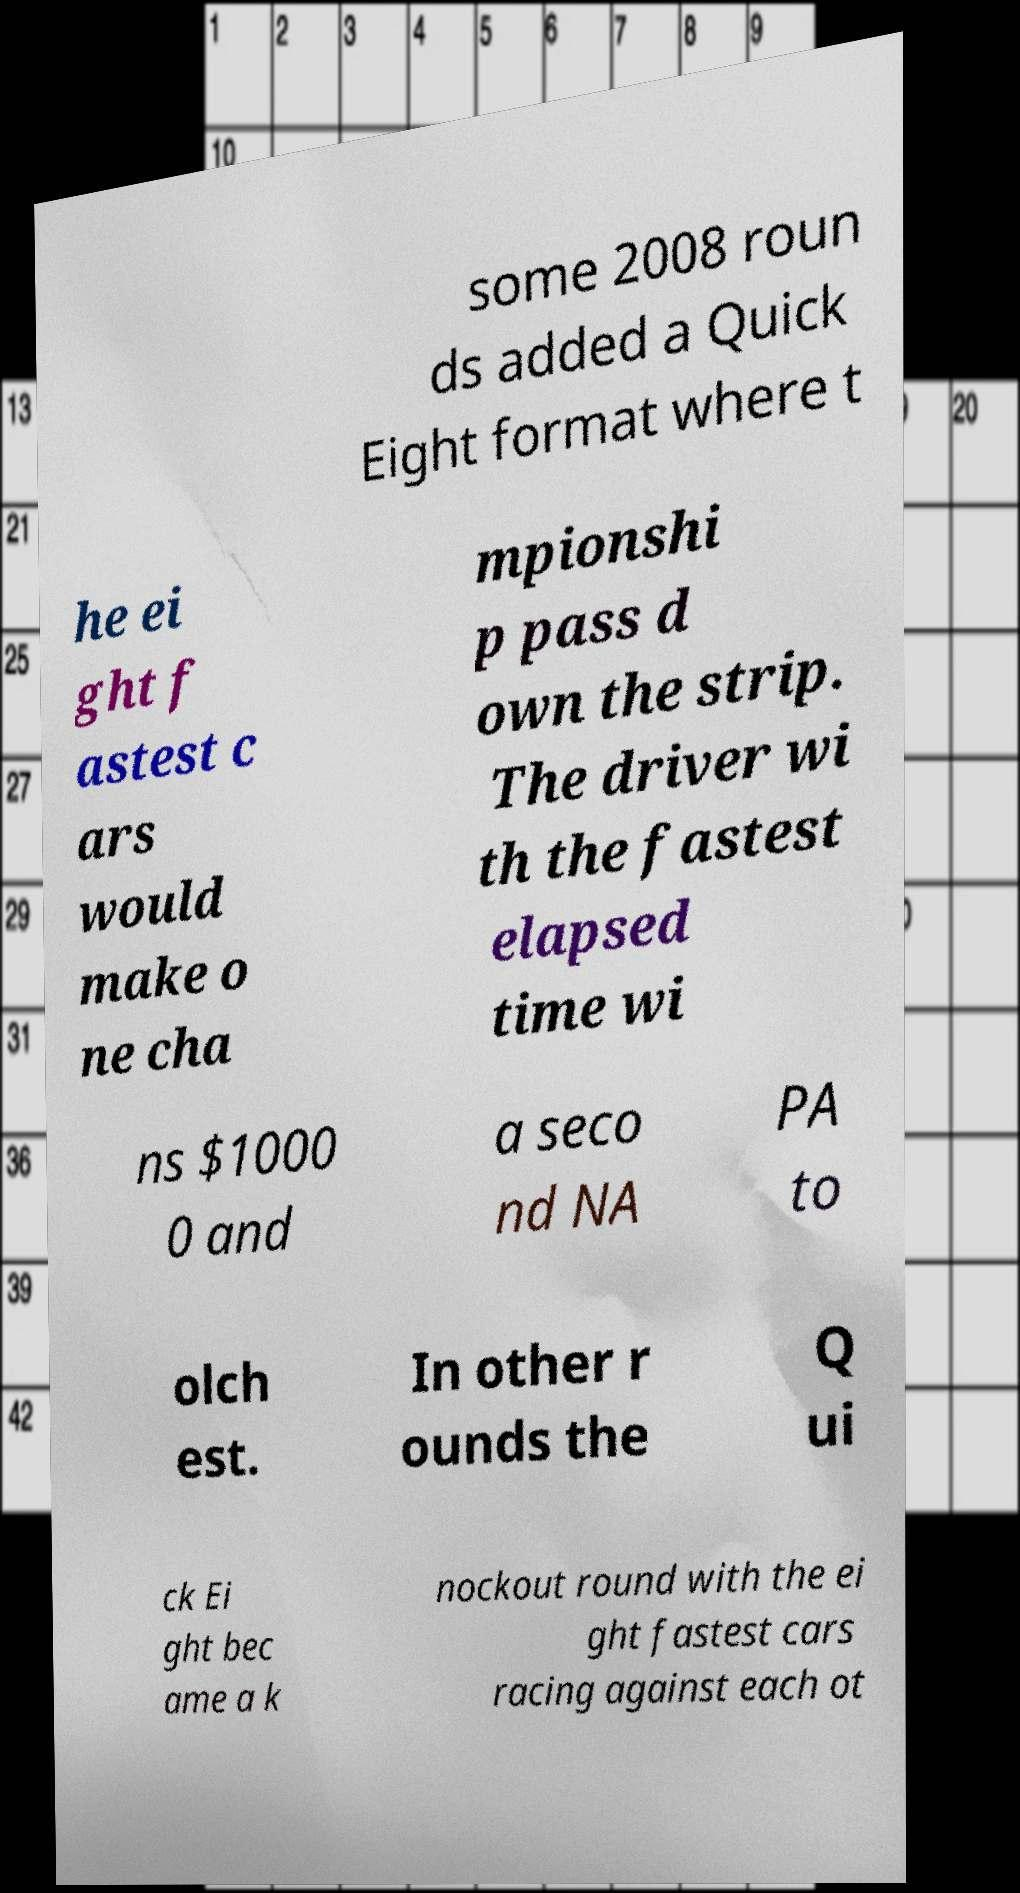There's text embedded in this image that I need extracted. Can you transcribe it verbatim? some 2008 roun ds added a Quick Eight format where t he ei ght f astest c ars would make o ne cha mpionshi p pass d own the strip. The driver wi th the fastest elapsed time wi ns $1000 0 and a seco nd NA PA to olch est. In other r ounds the Q ui ck Ei ght bec ame a k nockout round with the ei ght fastest cars racing against each ot 